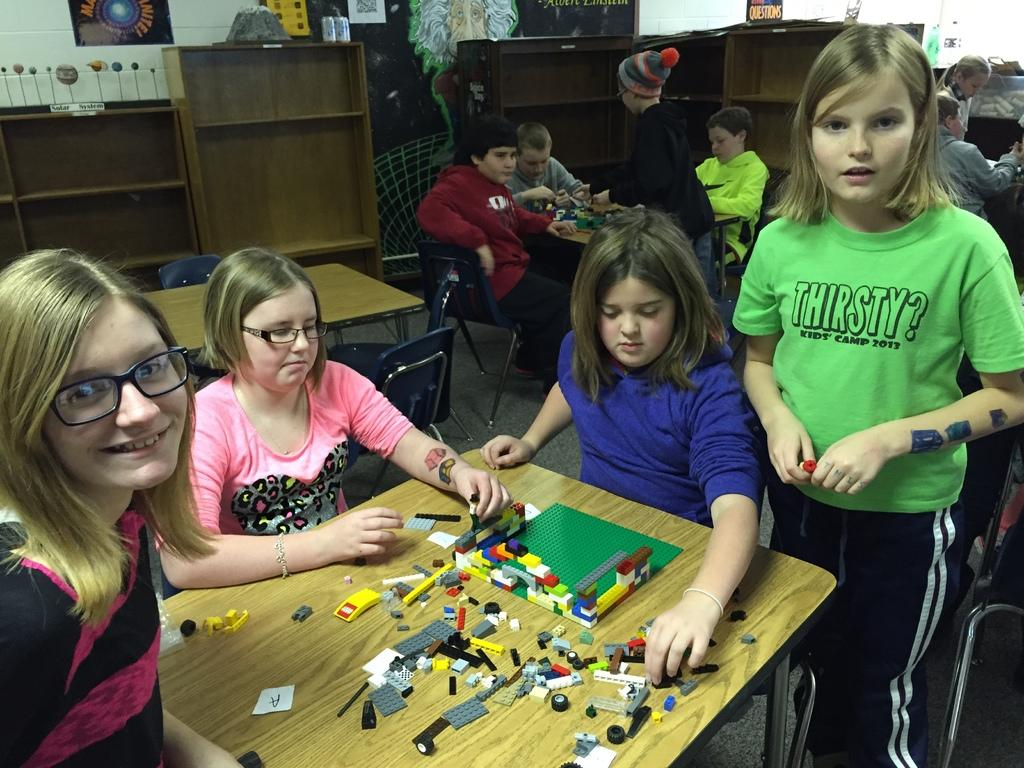How many children are present in the image? There are four girls and three boys in the image, making a total of seven children. What are the girls doing in the image? The girls are playing with toys in the image. Where are the toys located? The toys are kept on a table in the image. What are the boys doing in the background of the image? The boys are also playing with toys in the background of the image. Reasoning: Let's think step by breaking down the information provided step by step. We start by identifying the number of children in the image, which is seven. Then, we focus on the girls and their activities, noting that they are playing with toys. Next, we mention the location of the toys, which is on a table. Finally, we shift our attention to the boys in the background and their activities, which are similar to the girls - playing with toys. Absurd Question/Answer: What type of tent can be seen in the image? There is no tent present in the image. What kind of voyage are the children embarking on in the image? There is no indication of a voyage in the image; the children are simply playing with toys. 